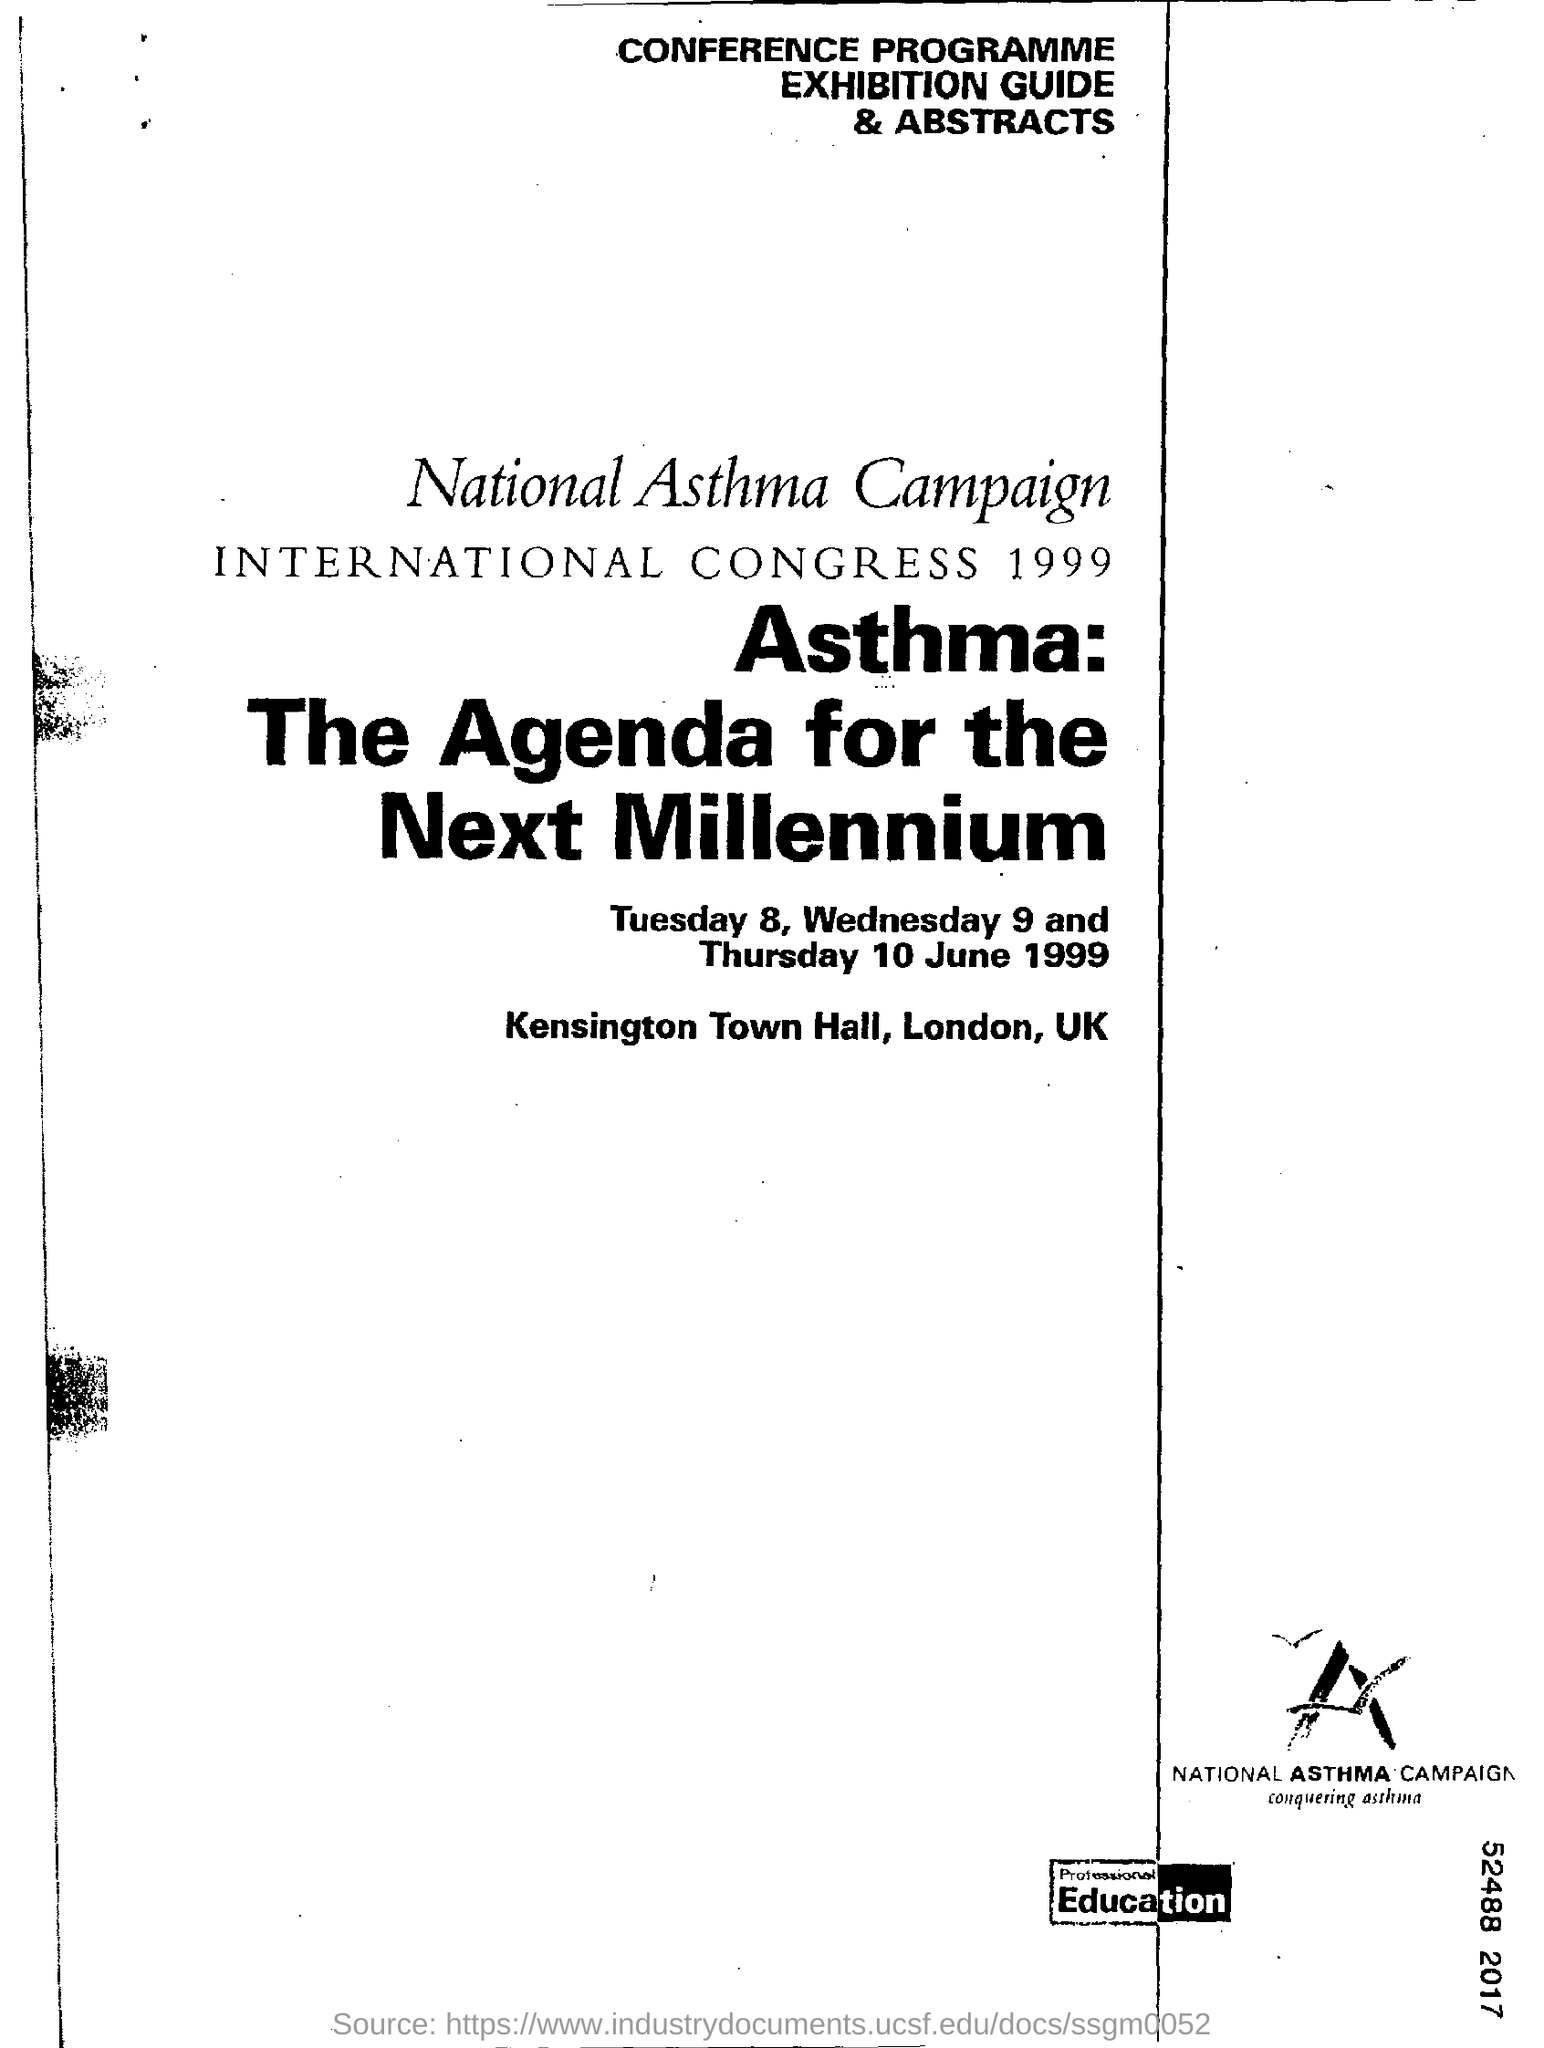Draw attention to some important aspects in this diagram. The International Congress 1999 was held at Kensington Town Hall in London, United Kingdom. The National Asthma Campaign was conducted in the year 1999. 